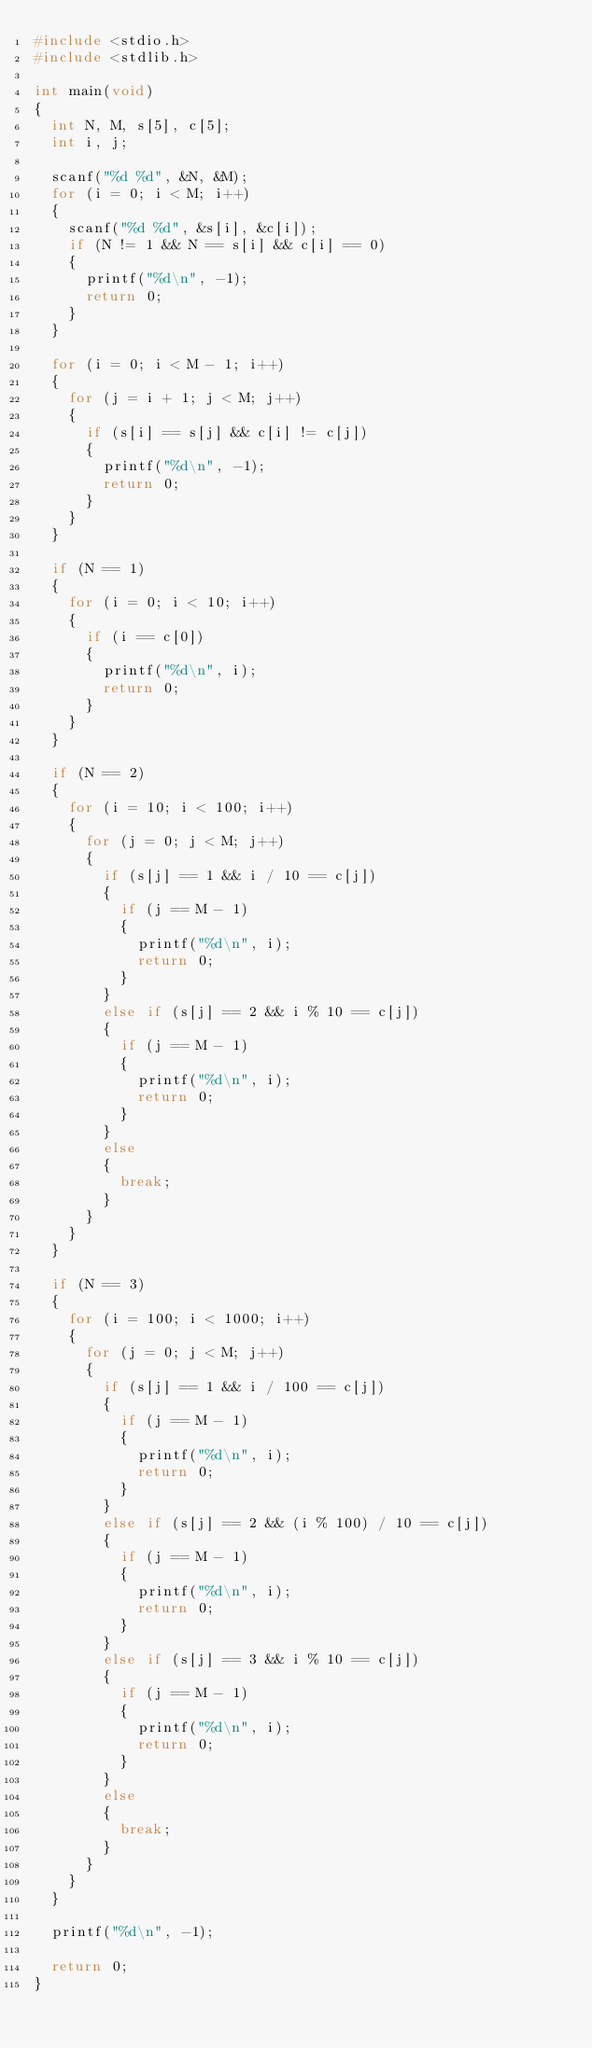Convert code to text. <code><loc_0><loc_0><loc_500><loc_500><_C_>#include <stdio.h>
#include <stdlib.h>

int main(void)
{
  int N, M, s[5], c[5];
  int i, j;
  
  scanf("%d %d", &N, &M);
  for (i = 0; i < M; i++)
  {
    scanf("%d %d", &s[i], &c[i]);
    if (N != 1 && N == s[i] && c[i] == 0)
    {
      printf("%d\n", -1);
      return 0;
    }
  }
  
  for (i = 0; i < M - 1; i++)
  {
    for (j = i + 1; j < M; j++)
    {
      if (s[i] == s[j] && c[i] != c[j])
      {
        printf("%d\n", -1);
        return 0;
      }
    }
  }
  
  if (N == 1)
  {
    for (i = 0; i < 10; i++)
    {
      if (i == c[0])
      {
        printf("%d\n", i);
        return 0;
      }
    }
  }
  
  if (N == 2)
  {
    for (i = 10; i < 100; i++)
    {
      for (j = 0; j < M; j++)
      {
        if (s[j] == 1 && i / 10 == c[j])
        {
          if (j == M - 1)
          {
            printf("%d\n", i);
            return 0;
          }
        }
        else if (s[j] == 2 && i % 10 == c[j])
        {
          if (j == M - 1)
          {
            printf("%d\n", i);
            return 0;
          }
        }
        else
        {
          break;
        }
      }
    }
  }
  
  if (N == 3)
  {
    for (i = 100; i < 1000; i++)
    {
      for (j = 0; j < M; j++)
      {
        if (s[j] == 1 && i / 100 == c[j])
        {
          if (j == M - 1)
          {
            printf("%d\n", i);
            return 0;
          }
        }
        else if (s[j] == 2 && (i % 100) / 10 == c[j])
        {
          if (j == M - 1)
          {
            printf("%d\n", i);
            return 0;
          }
        }
        else if (s[j] == 3 && i % 10 == c[j])
        {
          if (j == M - 1)
          {
            printf("%d\n", i);
            return 0;
          }
        }
        else
        {
          break;
        }
      }
    }
  }
  
  printf("%d\n", -1);
  
  return 0;
}</code> 